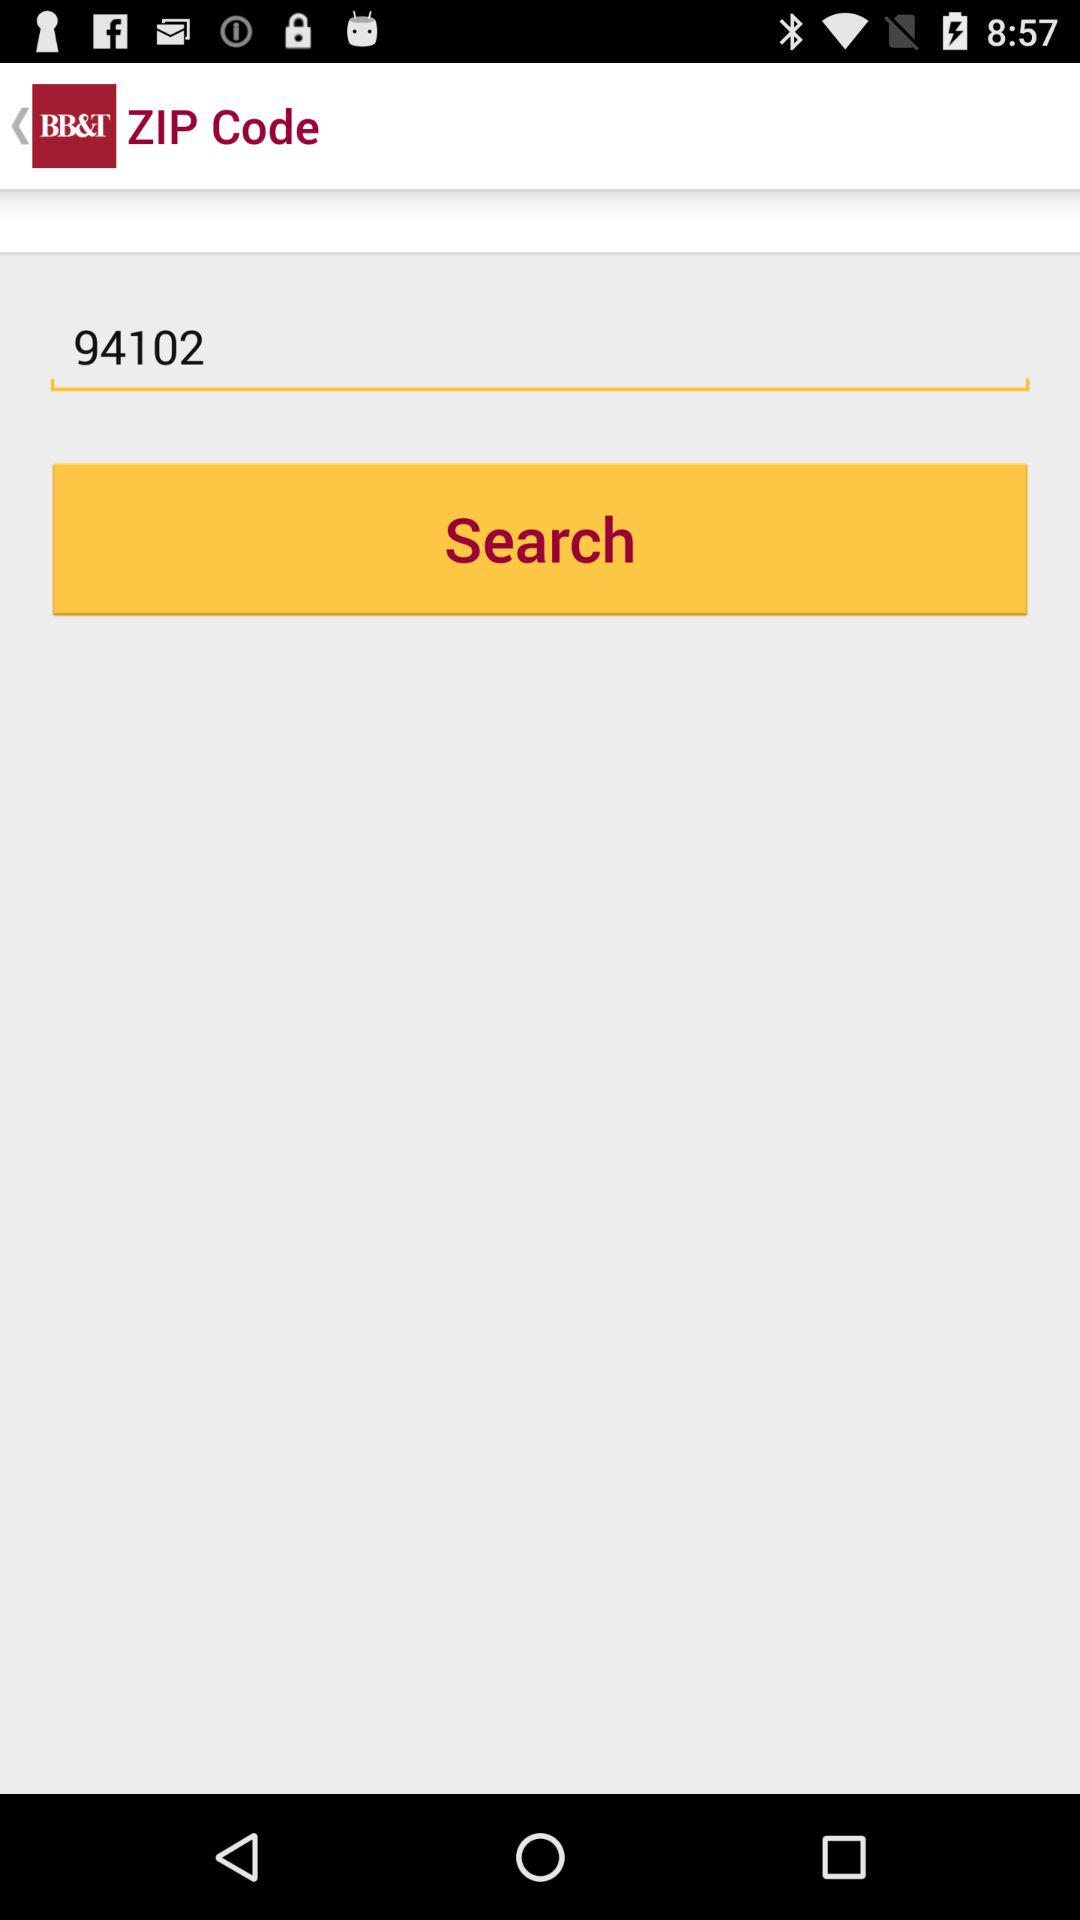Whose zip code is this?
When the provided information is insufficient, respond with <no answer>. <no answer> 